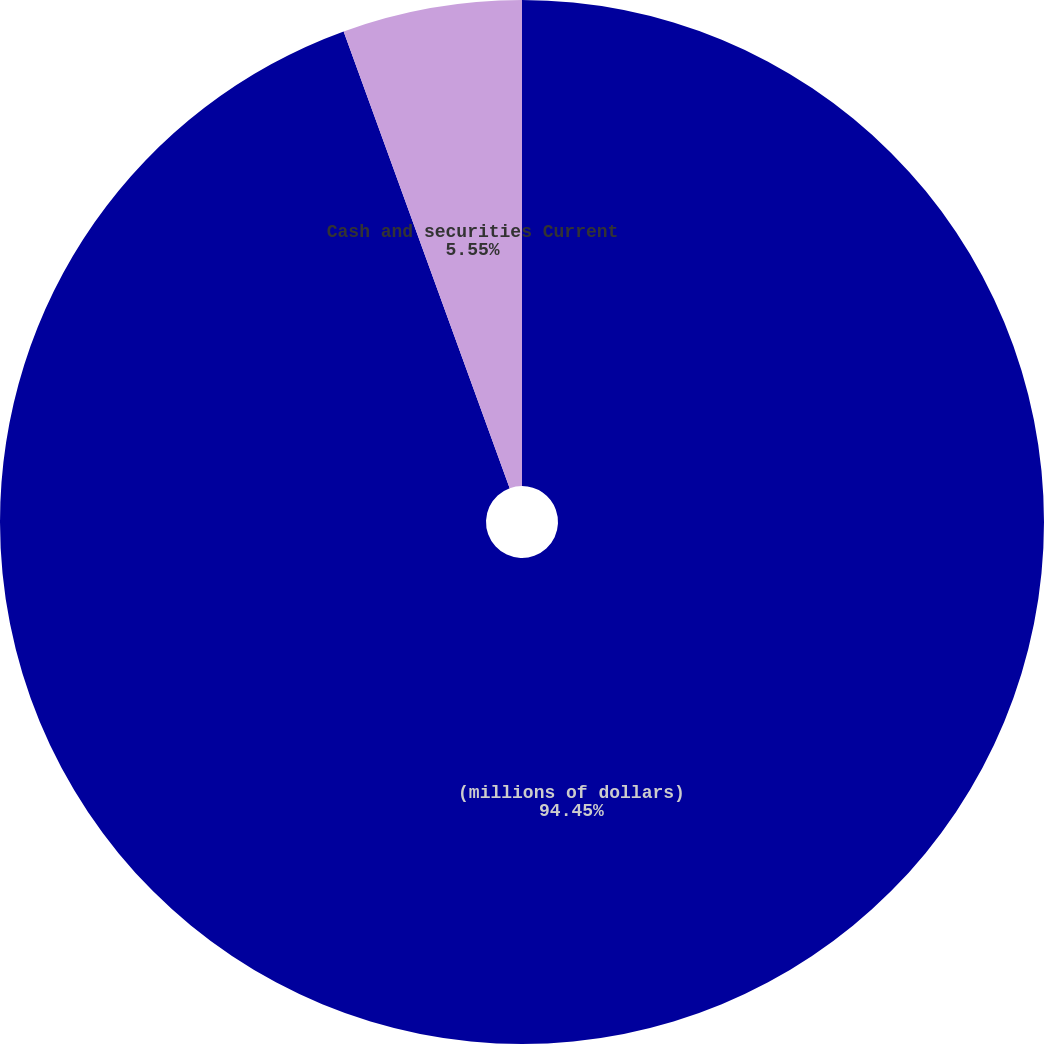Convert chart to OTSL. <chart><loc_0><loc_0><loc_500><loc_500><pie_chart><fcel>(millions of dollars)<fcel>Cash and securities Current<nl><fcel>94.45%<fcel>5.55%<nl></chart> 